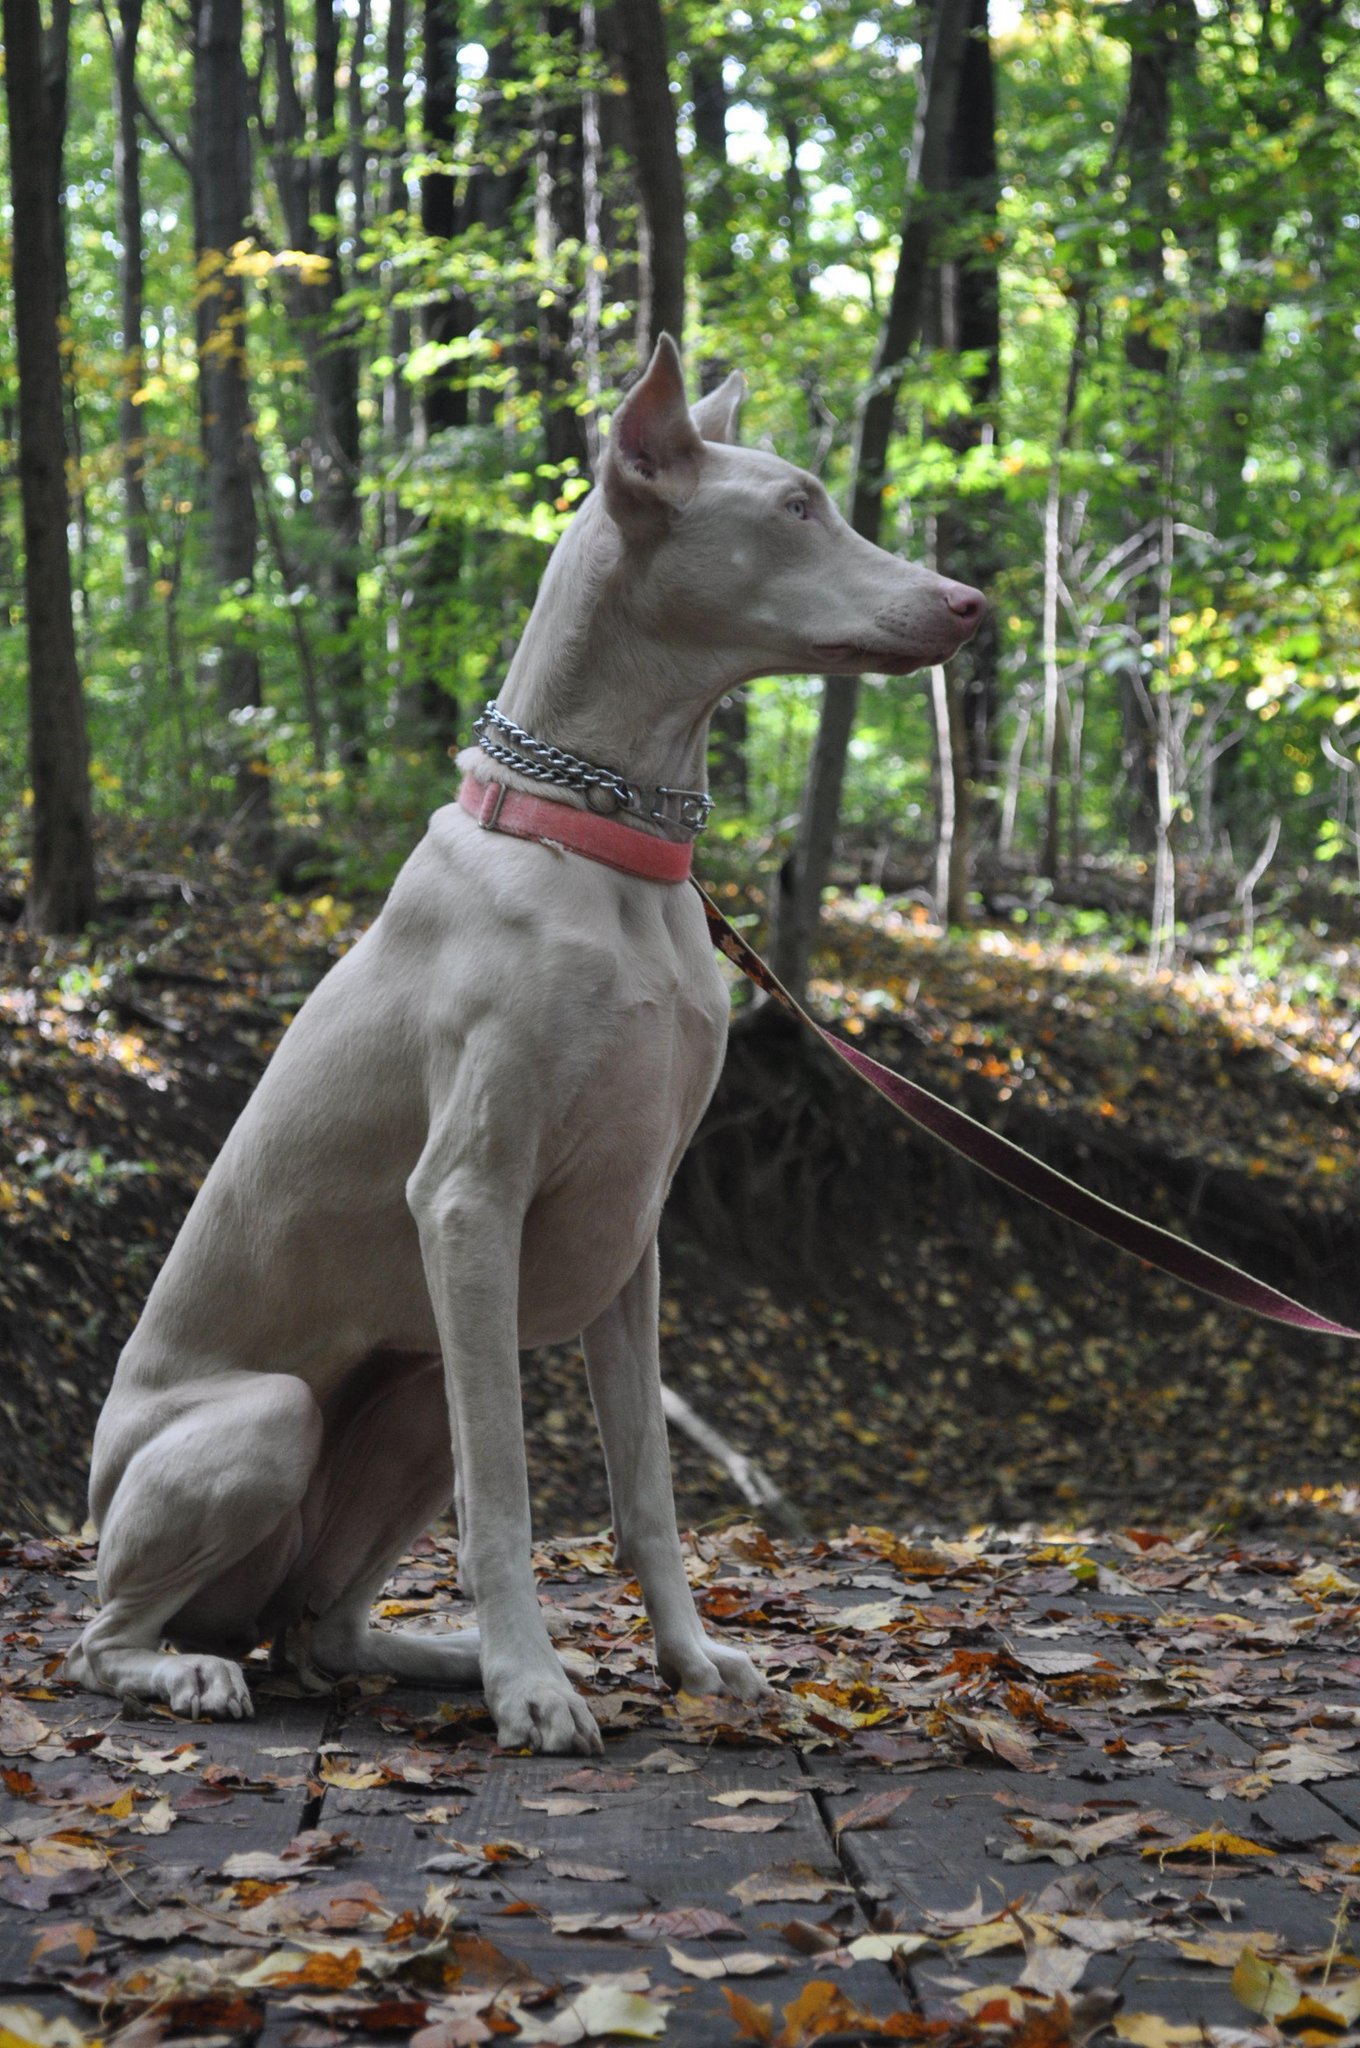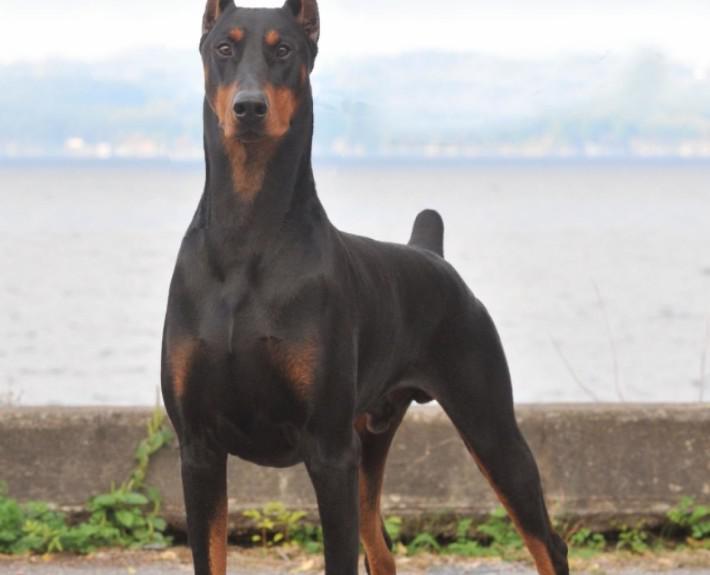The first image is the image on the left, the second image is the image on the right. Analyze the images presented: Is the assertion "There is only one dog with a collar" valid? Answer yes or no. Yes. The first image is the image on the left, the second image is the image on the right. For the images displayed, is the sentence "The right image features a pointy-eared black-and-tan doberman with docked tail standing with its body turned leftward." factually correct? Answer yes or no. Yes. 